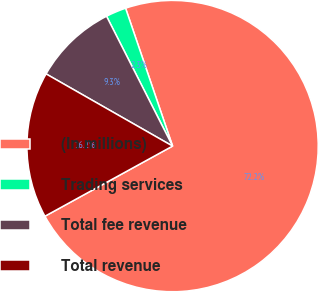Convert chart to OTSL. <chart><loc_0><loc_0><loc_500><loc_500><pie_chart><fcel>(In millions)<fcel>Trading services<fcel>Total fee revenue<fcel>Total revenue<nl><fcel>72.23%<fcel>2.26%<fcel>9.26%<fcel>16.25%<nl></chart> 